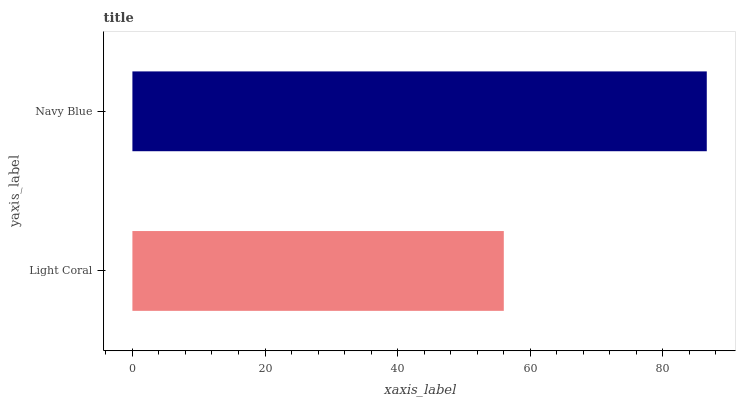Is Light Coral the minimum?
Answer yes or no. Yes. Is Navy Blue the maximum?
Answer yes or no. Yes. Is Navy Blue the minimum?
Answer yes or no. No. Is Navy Blue greater than Light Coral?
Answer yes or no. Yes. Is Light Coral less than Navy Blue?
Answer yes or no. Yes. Is Light Coral greater than Navy Blue?
Answer yes or no. No. Is Navy Blue less than Light Coral?
Answer yes or no. No. Is Navy Blue the high median?
Answer yes or no. Yes. Is Light Coral the low median?
Answer yes or no. Yes. Is Light Coral the high median?
Answer yes or no. No. Is Navy Blue the low median?
Answer yes or no. No. 